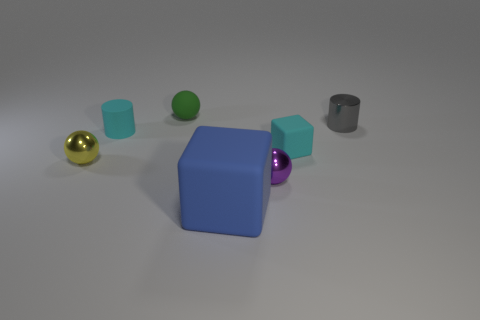Add 3 tiny purple spheres. How many objects exist? 10 Subtract all cylinders. How many objects are left? 5 Add 4 tiny yellow spheres. How many tiny yellow spheres exist? 5 Subtract 1 cyan cylinders. How many objects are left? 6 Subtract all large gray matte things. Subtract all cyan cylinders. How many objects are left? 6 Add 3 rubber objects. How many rubber objects are left? 7 